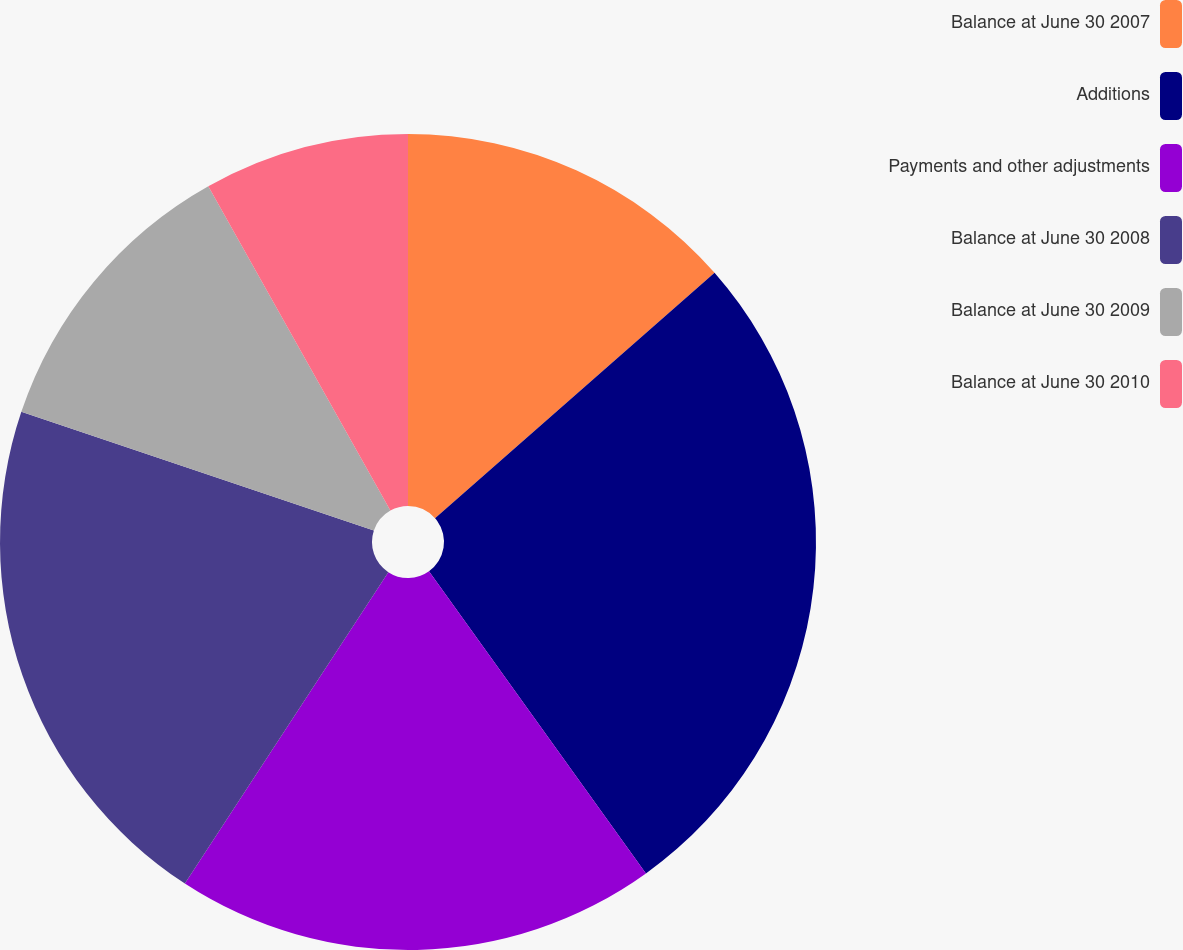Convert chart. <chart><loc_0><loc_0><loc_500><loc_500><pie_chart><fcel>Balance at June 30 2007<fcel>Additions<fcel>Payments and other adjustments<fcel>Balance at June 30 2008<fcel>Balance at June 30 2009<fcel>Balance at June 30 2010<nl><fcel>13.53%<fcel>26.56%<fcel>19.12%<fcel>20.96%<fcel>11.69%<fcel>8.14%<nl></chart> 